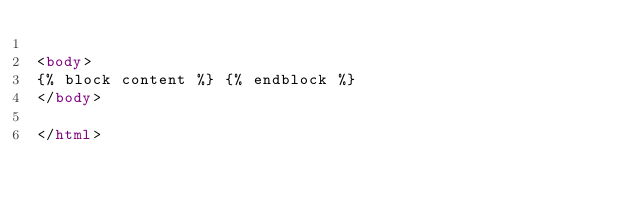<code> <loc_0><loc_0><loc_500><loc_500><_HTML_>
<body>
{% block content %} {% endblock %}
</body>

</html>
</code> 